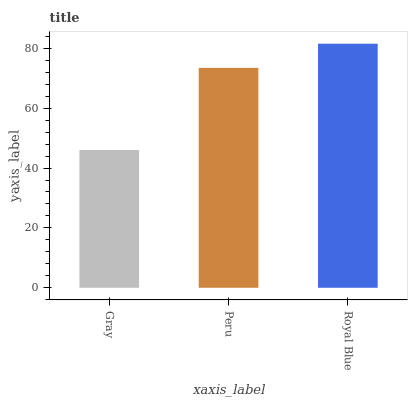Is Gray the minimum?
Answer yes or no. Yes. Is Royal Blue the maximum?
Answer yes or no. Yes. Is Peru the minimum?
Answer yes or no. No. Is Peru the maximum?
Answer yes or no. No. Is Peru greater than Gray?
Answer yes or no. Yes. Is Gray less than Peru?
Answer yes or no. Yes. Is Gray greater than Peru?
Answer yes or no. No. Is Peru less than Gray?
Answer yes or no. No. Is Peru the high median?
Answer yes or no. Yes. Is Peru the low median?
Answer yes or no. Yes. Is Royal Blue the high median?
Answer yes or no. No. Is Gray the low median?
Answer yes or no. No. 